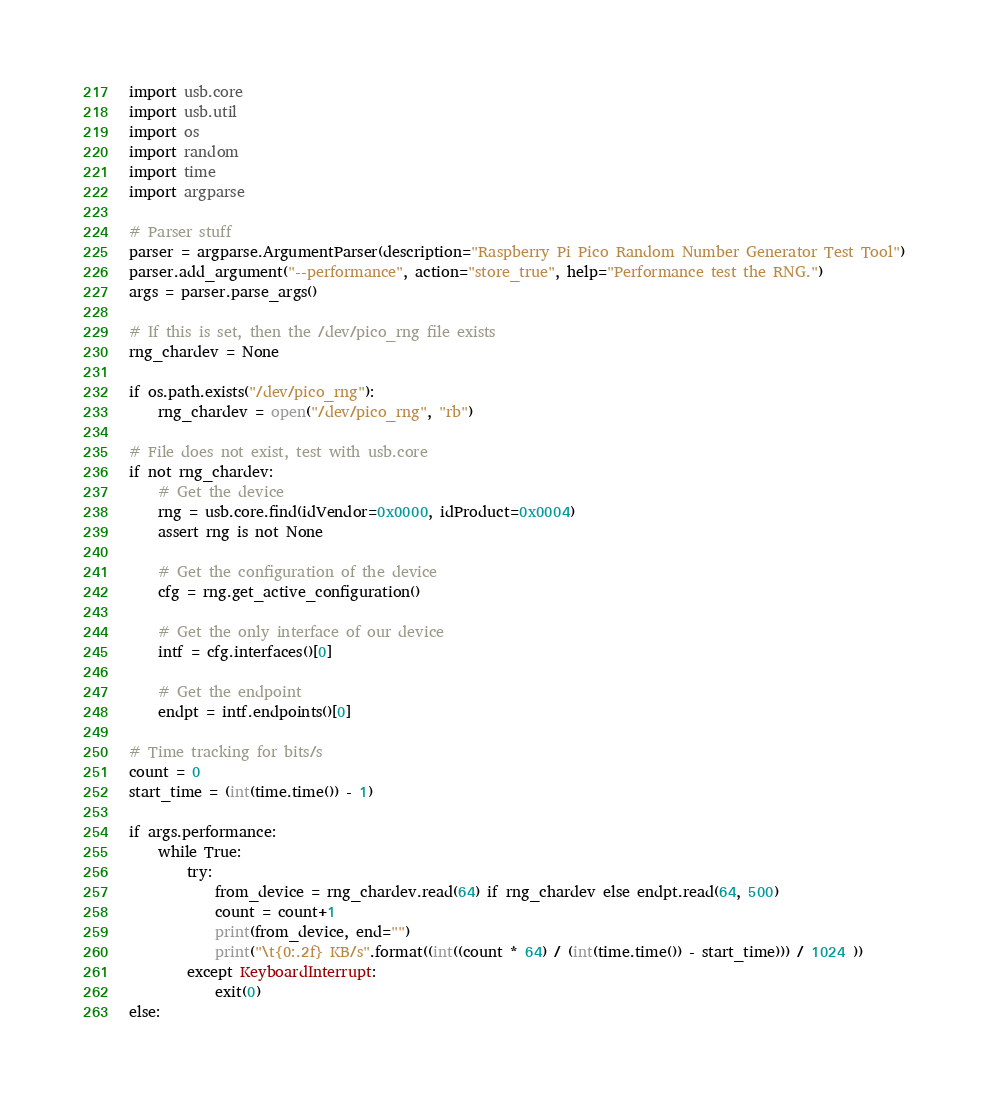<code> <loc_0><loc_0><loc_500><loc_500><_Python_>import usb.core
import usb.util
import os
import random
import time
import argparse

# Parser stuff
parser = argparse.ArgumentParser(description="Raspberry Pi Pico Random Number Generator Test Tool")
parser.add_argument("--performance", action="store_true", help="Performance test the RNG.")
args = parser.parse_args()

# If this is set, then the /dev/pico_rng file exists
rng_chardev = None

if os.path.exists("/dev/pico_rng"):
    rng_chardev = open("/dev/pico_rng", "rb")
    
# File does not exist, test with usb.core
if not rng_chardev:
    # Get the device
    rng = usb.core.find(idVendor=0x0000, idProduct=0x0004)
    assert rng is not None

    # Get the configuration of the device
    cfg = rng.get_active_configuration()

    # Get the only interface of our device
    intf = cfg.interfaces()[0]

    # Get the endpoint
    endpt = intf.endpoints()[0]

# Time tracking for bits/s
count = 0
start_time = (int(time.time()) - 1)

if args.performance:
    while True:
        try:
            from_device = rng_chardev.read(64) if rng_chardev else endpt.read(64, 500)
            count = count+1
            print(from_device, end="")
            print("\t{0:.2f} KB/s".format((int((count * 64) / (int(time.time()) - start_time))) / 1024 ))
        except KeyboardInterrupt:
            exit(0)
else:</code> 